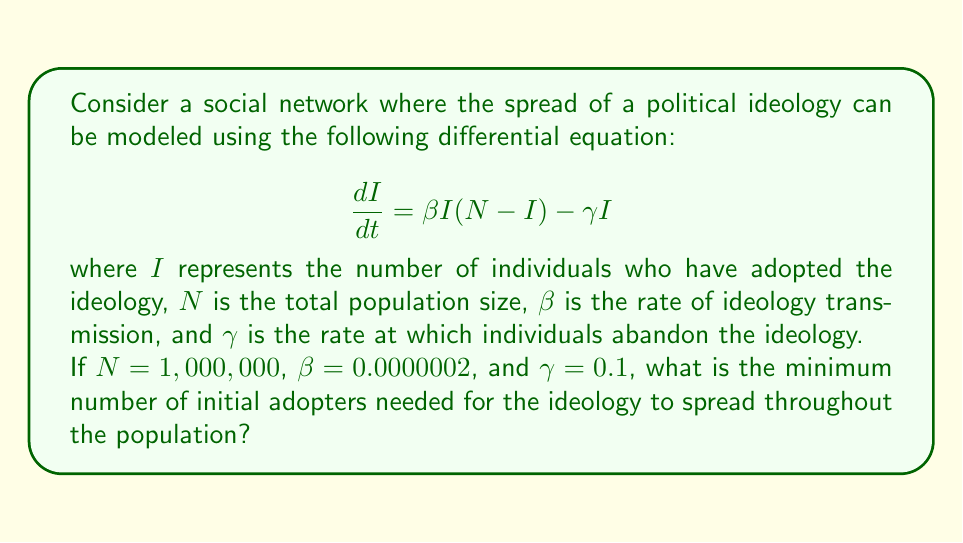Provide a solution to this math problem. To solve this problem, we need to find the critical threshold for the spread of the ideology. This occurs when $\frac{dI}{dt} = 0$, which represents the equilibrium point.

1) Set the equation equal to zero:
   $$0 = \beta I(N-I) - \gamma I$$

2) Factor out $I$:
   $$0 = I(\beta N - \beta I - \gamma)$$

3) Solve for $I$ (ignoring the trivial solution $I = 0$):
   $$\beta N - \beta I - \gamma = 0$$
   $$\beta N - \gamma = \beta I$$
   $$I = \frac{\beta N - \gamma}{\beta}$$

4) This is the critical threshold. For the ideology to spread, we need:
   $$I > \frac{\beta N - \gamma}{\beta}$$

5) Substitute the given values:
   $$I > \frac{(0.0000002 \times 1,000,000) - 0.1}{0.0000002}$$
   $$I > \frac{0.2 - 0.1}{0.0000002}$$
   $$I > 500,000$$

6) Since we need a whole number of people, we round up to the nearest integer.

Therefore, the minimum number of initial adopters needed is 500,001.
Answer: 500,001 